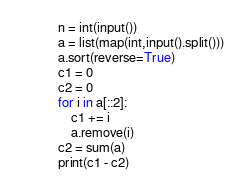Convert code to text. <code><loc_0><loc_0><loc_500><loc_500><_Python_>n = int(input())
a = list(map(int,input().split()))
a.sort(reverse=True)
c1 = 0
c2 = 0
for i in a[::2]:
    c1 += i
    a.remove(i)
c2 = sum(a)
print(c1 - c2)</code> 